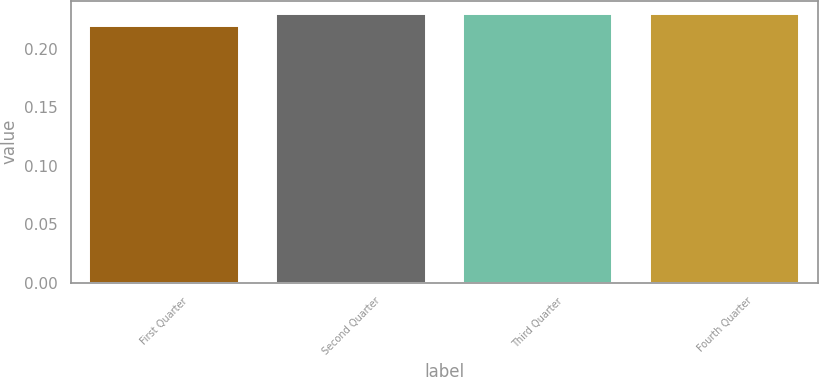Convert chart. <chart><loc_0><loc_0><loc_500><loc_500><bar_chart><fcel>First Quarter<fcel>Second Quarter<fcel>Third Quarter<fcel>Fourth Quarter<nl><fcel>0.22<fcel>0.23<fcel>0.23<fcel>0.23<nl></chart> 